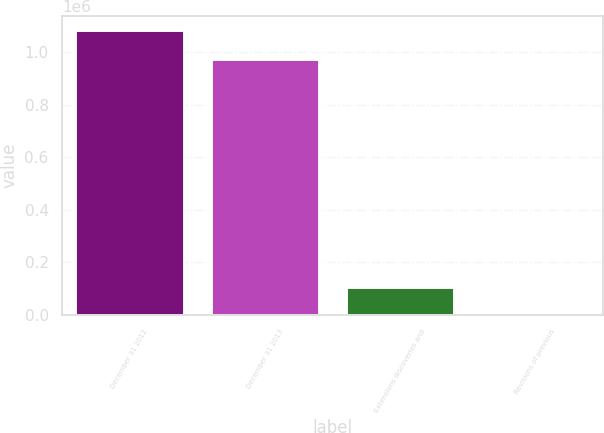Convert chart. <chart><loc_0><loc_0><loc_500><loc_500><bar_chart><fcel>December 31 2012<fcel>December 31 2013<fcel>Extensions discoveries and<fcel>Revisions of previous<nl><fcel>1.08262e+06<fcel>975224<fcel>107493<fcel>101<nl></chart> 